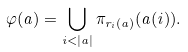Convert formula to latex. <formula><loc_0><loc_0><loc_500><loc_500>\varphi ( a ) = \bigcup _ { i < | a | } \pi _ { r _ { i } ( a ) } ( a ( i ) ) .</formula> 